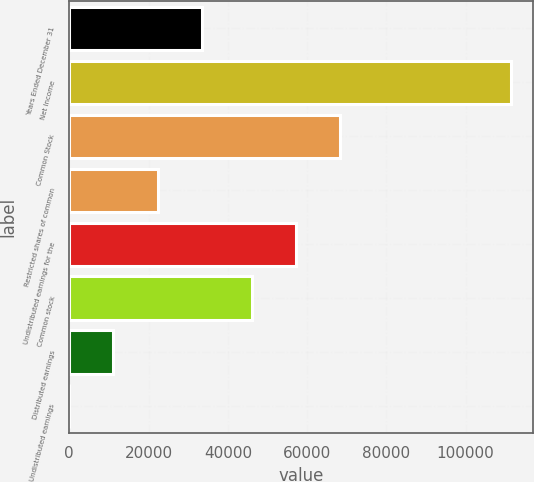Convert chart to OTSL. <chart><loc_0><loc_0><loc_500><loc_500><bar_chart><fcel>Years Ended December 31<fcel>Net Income<fcel>Common Stock<fcel>Restricted shares of common<fcel>Undistributed earnings for the<fcel>Common stock<fcel>Distributed earnings<fcel>Undistributed earnings<nl><fcel>33399.8<fcel>111332<fcel>68416.3<fcel>22266.7<fcel>57283.2<fcel>46150<fcel>11133.5<fcel>0.32<nl></chart> 